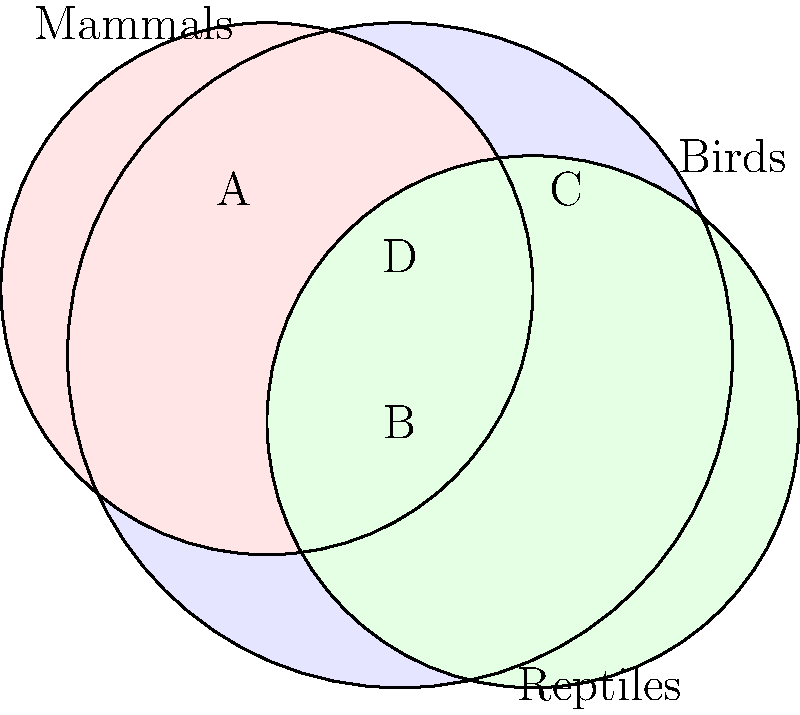In a study of animal classification, three sets are defined: Mammals (M), Birds (B), and Reptiles (R). The Venn diagram above represents these sets. Given that there are 100 species in total, and the number of species in each region is directly proportional to its area, what is the minimum number of species that must be reclassified to ensure a clear separation between all three groups? To solve this problem, we need to follow these steps:

1) Identify the regions of overlap:
   A: Mammals ∩ Birds
   B: Mammals ∩ Reptiles ∩ Birds
   C: Reptiles ∩ Birds
   D: Mammals ∩ Reptiles

2) To achieve a clear separation, we need to reclassify all species in these overlapping regions.

3) The total number of species to be reclassified is the sum of species in A, B, C, and D.

4) Since the number of species is proportional to the area, and there are 100 species in total, we can estimate the number of species in each region based on its relative size in the diagram:

   A ≈ 10 species
   B ≈ 5 species
   C ≈ 10 species
   D ≈ 10 species

5) The total number of species to be reclassified:
   $10 + 5 + 10 + 10 = 35$ species

Therefore, a minimum of 35 species must be reclassified to ensure a clear separation between mammals, birds, and reptiles.
Answer: 35 species 